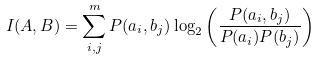Convert formula to latex. <formula><loc_0><loc_0><loc_500><loc_500>I ( A , B ) = \sum _ { i , j } ^ { m } P ( a _ { i } , b _ { j } ) \log _ { 2 } \left ( \frac { P ( a _ { i } , b _ { j } ) } { P ( a _ { i } ) P ( b _ { j } ) } \right )</formula> 